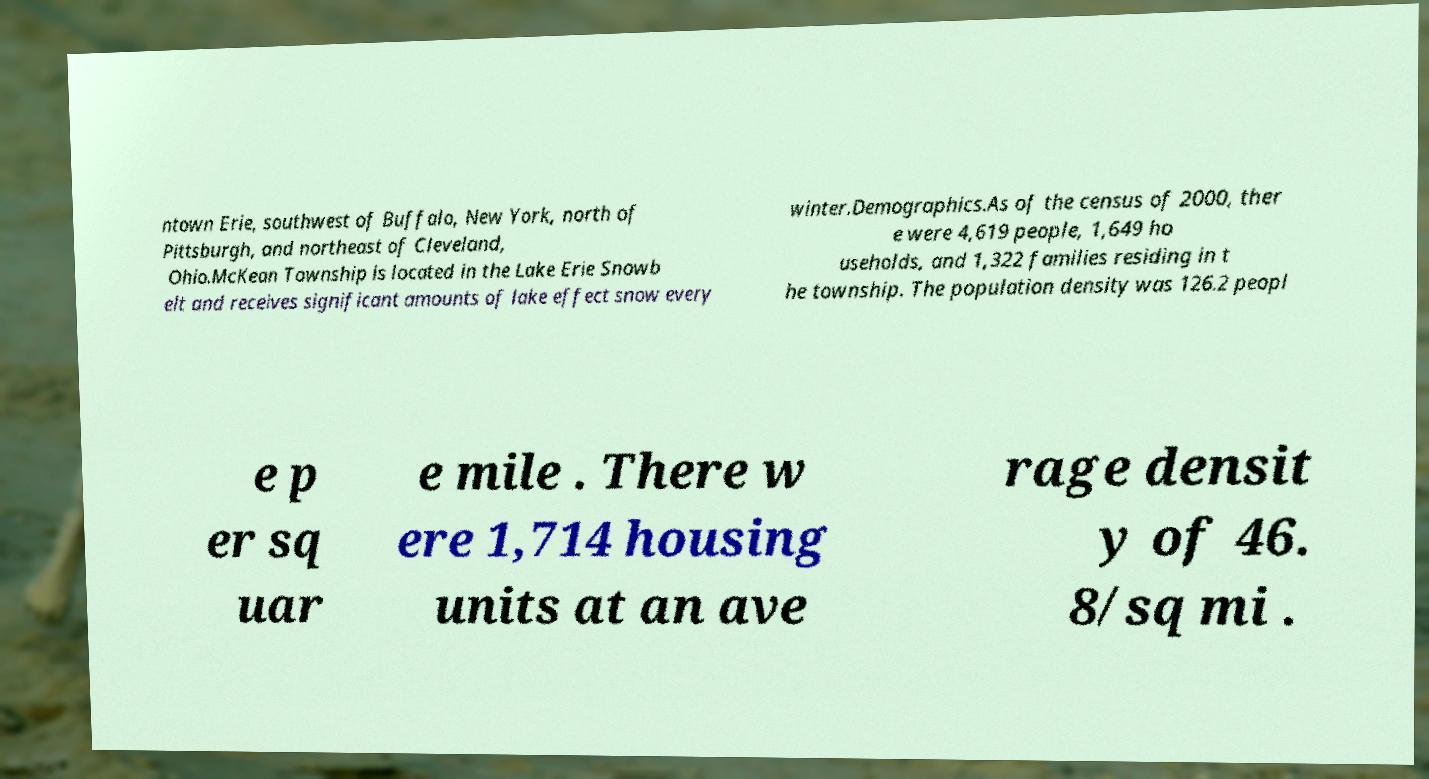I need the written content from this picture converted into text. Can you do that? ntown Erie, southwest of Buffalo, New York, north of Pittsburgh, and northeast of Cleveland, Ohio.McKean Township is located in the Lake Erie Snowb elt and receives significant amounts of lake effect snow every winter.Demographics.As of the census of 2000, ther e were 4,619 people, 1,649 ho useholds, and 1,322 families residing in t he township. The population density was 126.2 peopl e p er sq uar e mile . There w ere 1,714 housing units at an ave rage densit y of 46. 8/sq mi . 